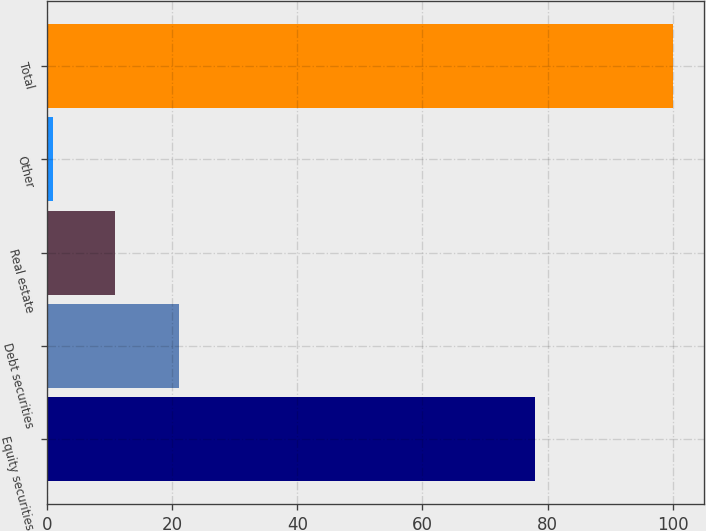<chart> <loc_0><loc_0><loc_500><loc_500><bar_chart><fcel>Equity securities<fcel>Debt securities<fcel>Real estate<fcel>Other<fcel>Total<nl><fcel>78<fcel>21<fcel>10.9<fcel>1<fcel>100<nl></chart> 